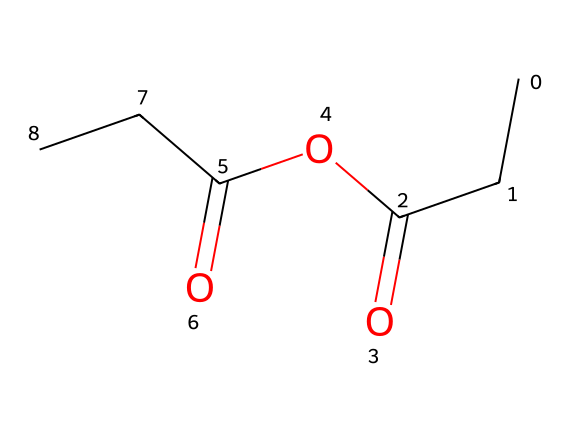how many carbon atoms are in this structure? The SMILES representation shows a total of five 'C' characters, which indicates five carbon atoms are present in the structure.
Answer: five what functional groups are present in propionic anhydride? Anhydrides are characterized by the presence of two acyl groups (derived from acids) linked by an oxygen atom. In the case of propionic anhydride, we can see the group containing 'C(=O)' two times indicating that there are two propionyl groups.
Answer: anhydride, propionyl what type of bond connects the carbon and oxygen in the carbonyl groups? The 'C(=O)' notation indicates a double bond between the carbon and oxygen in the carbonyl groups. This connection is a hallmark of carbonyl functionalities in organic molecules.
Answer: double bond is propionic anhydride a saturated or unsaturated compound? The presence of only single and double bonds (but no triple bonds) in the structure indicates that it is saturated with respect to the carbon chains, despite the presence of carbonyl groups.
Answer: saturated how does the structure of propionic anhydride influence its role as a preservative? The anhydride structure typically leads to reactivity with moisture and other nucleophiles, allowing it to form derivatives that can inhibit microbial growth, thus extending shelf life. This reactivity, stemming from the functional groups present and the molecular structure, is crucial for its preservative properties.
Answer: reactivity what are the total number of oxygen atoms in propionic anhydride? In the provided SMILES, we can count the number of 'O' characters, which amounts to three, thus indicating three oxygen atoms within the structure.
Answer: three 